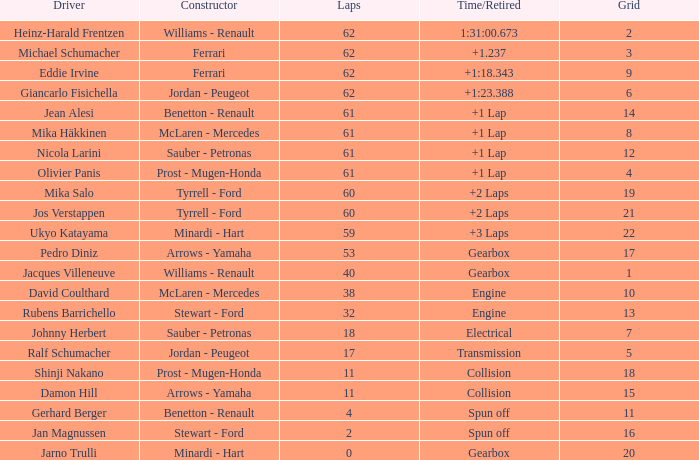What is the mean count of laps with a time/retired of +1 lap, an olivier panis as the driver, and a grid greater than 4? None. 